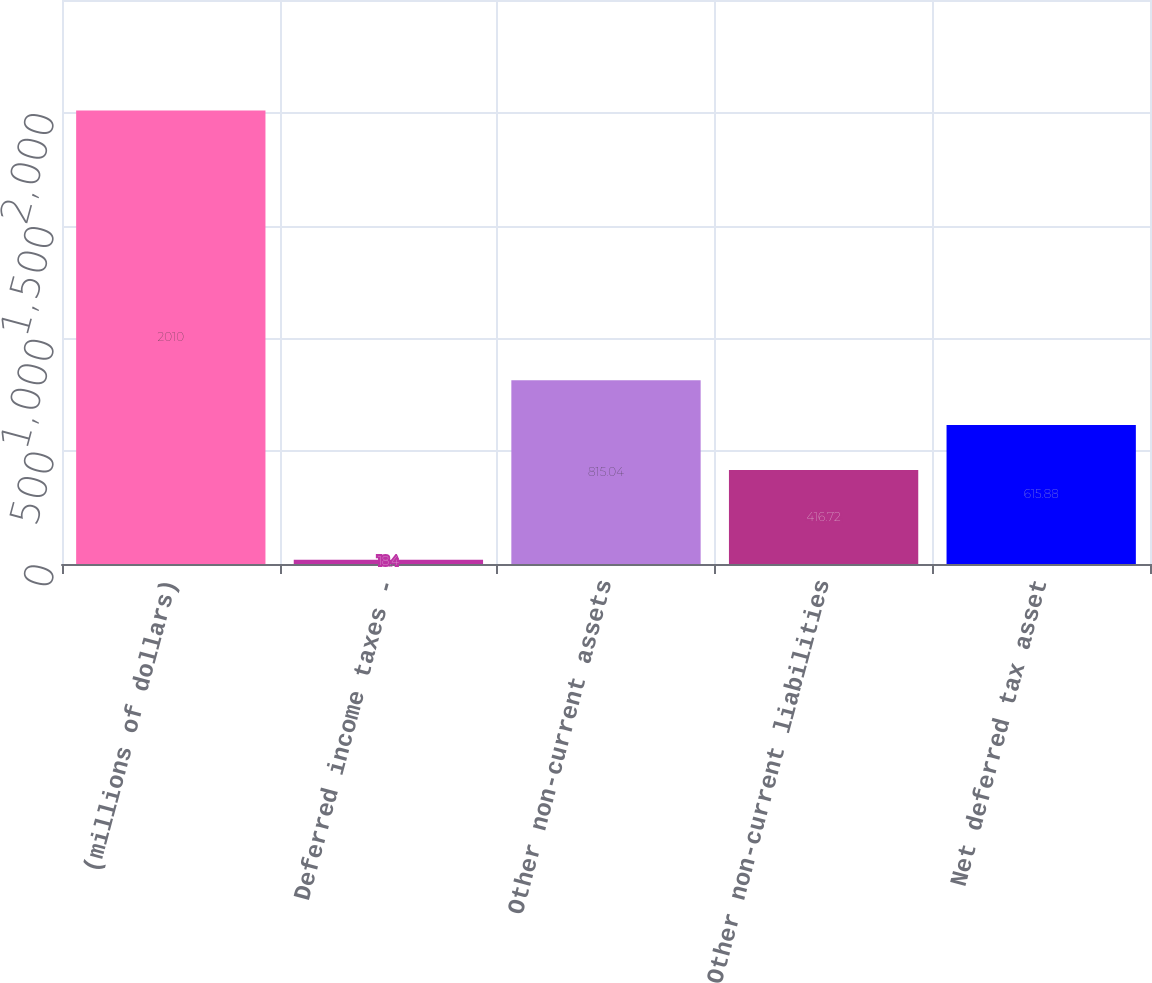Convert chart. <chart><loc_0><loc_0><loc_500><loc_500><bar_chart><fcel>(millions of dollars)<fcel>Deferred income taxes -<fcel>Other non-current assets<fcel>Other non-current liabilities<fcel>Net deferred tax asset<nl><fcel>2010<fcel>18.4<fcel>815.04<fcel>416.72<fcel>615.88<nl></chart> 